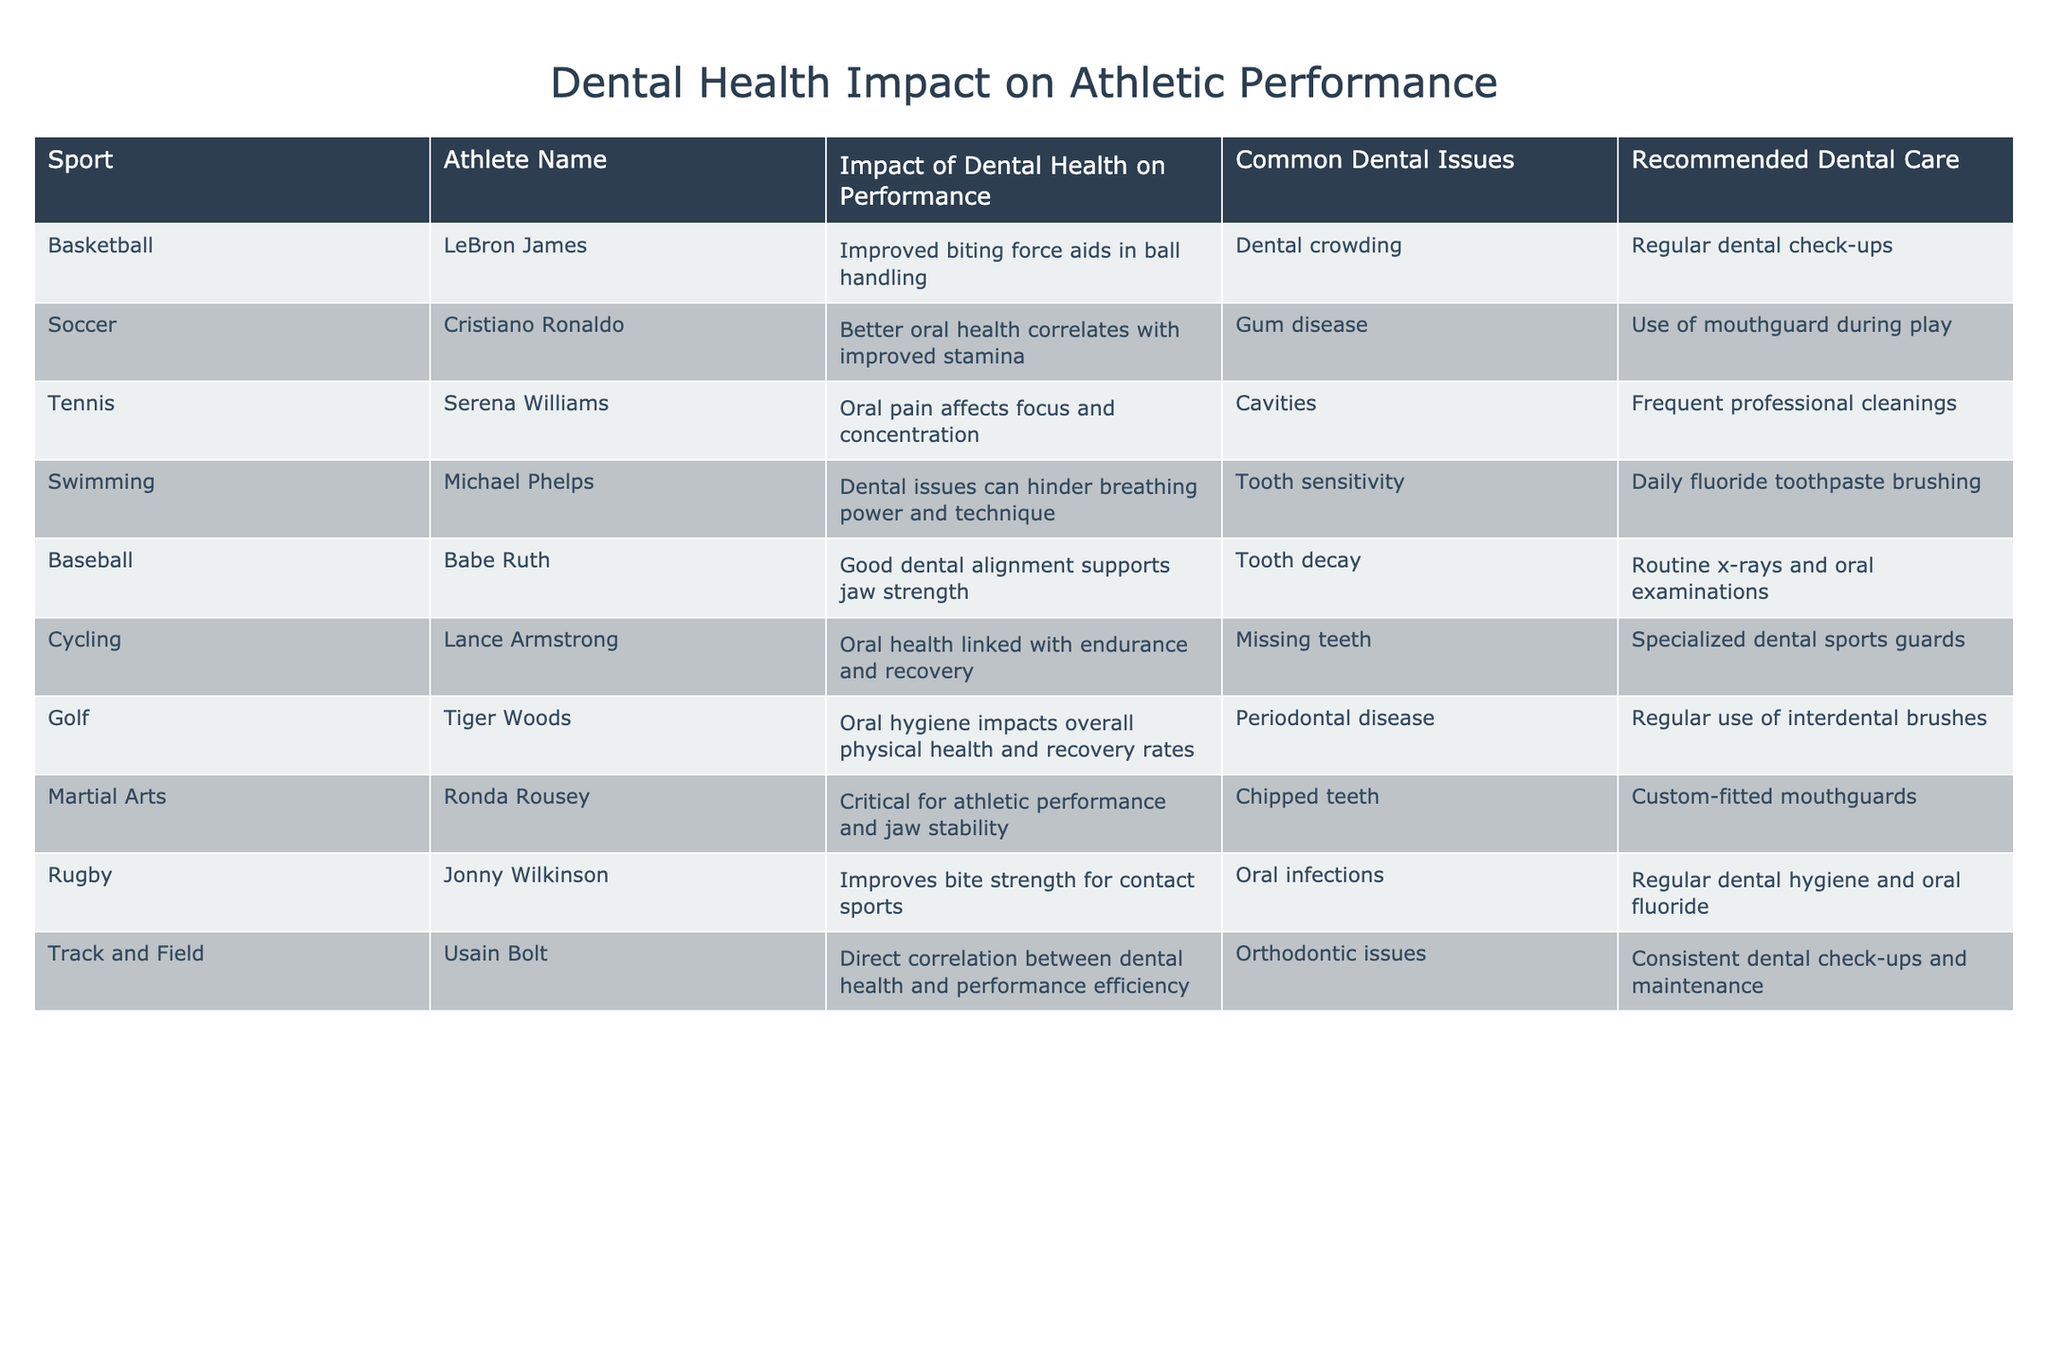What sport does Ronda Rousey participate in? By looking at the data, Ronda Rousey is listed under the "Martial Arts" category.
Answer: Martial Arts Which athlete's performance is impacted by gum disease? The table indicates that Cristiano Ronaldo, who plays soccer, has his performance correlating with gum disease.
Answer: Cristiano Ronaldo What common dental issue is associated with LeBron James? LeBron James faces the common dental issue of dental crowding as stated in the table.
Answer: Dental crowding Which sport has a recommended dental care of "Use of mouthguard during play"? The table shows that this recommendation is related to the sport of soccer, where Cristiano Ronaldo is the athlete.
Answer: Soccer Which athlete has the highest correlation between dental health and performance efficiency? The athlete Usain Bolt in Track and Field has a direct correlation between dental health and performance efficiency according to the table.
Answer: Usain Bolt What impact does dental health have on Michael Phelps' swimming technique? The data suggests that dental issues can hinder Michael Phelps' breathing power and technique in swimming.
Answer: Hinder breathing power and technique Which two athletes are recommended to maintain consistent dental check-ups? According to the table, Usain Bolt and LeBron James are both recommended to maintain consistent dental check-ups and regular dental check-ups, respectively.
Answer: Usain Bolt and LeBron James Is there a dental health recommendation for Tiger Woods? Yes, the table indicates that Tiger Woods is recommended to use interdental brushes regularly.
Answer: Yes How many sports listed have dental issues related to chewing strength? By examining the table, basketball and rugby both mention impacts on biting strength, totaling two sports.
Answer: Two sports What is the common dental issue for athletes in cycling? The table shows that missing teeth is the common dental issue for Lance Armstrong, the cyclist.
Answer: Missing teeth Which athlete faces oral pain affecting their focus and concentration? Serena Williams, the tennis player, experiences oral pain affecting her focus and concentration.
Answer: Serena Williams What do Babe Ruth and Tiger Woods have in common regarding dental health? Both athletes are recommended for regular dental care; Babe Ruth for routine x-rays and oral examinations, and Tiger Woods for regular use of interdental brushes.
Answer: Regular dental care Do dental issues impact performance for all listed athletes? Yes, every athlete listed has had their performance affected by some form of dental issue.
Answer: Yes Which sport is associated with the severity of periodontal disease? The data indicates that Tiger Woods in golf faces issues related to periodontal disease.
Answer: Golf How does Lance Armstrong's dental health relate to his endurance? The table notes that Lance Armstrong's oral health is linked with his endurance and recovery in cycling.
Answer: Linked with endurance and recovery What is the relationship between dental health and athletic recovery rates for Tiger Woods? The data highlights that Tiger Woods' oral hygiene significantly impacts his overall physical health and recovery rates.
Answer: Impacts overall health and recovery rates 